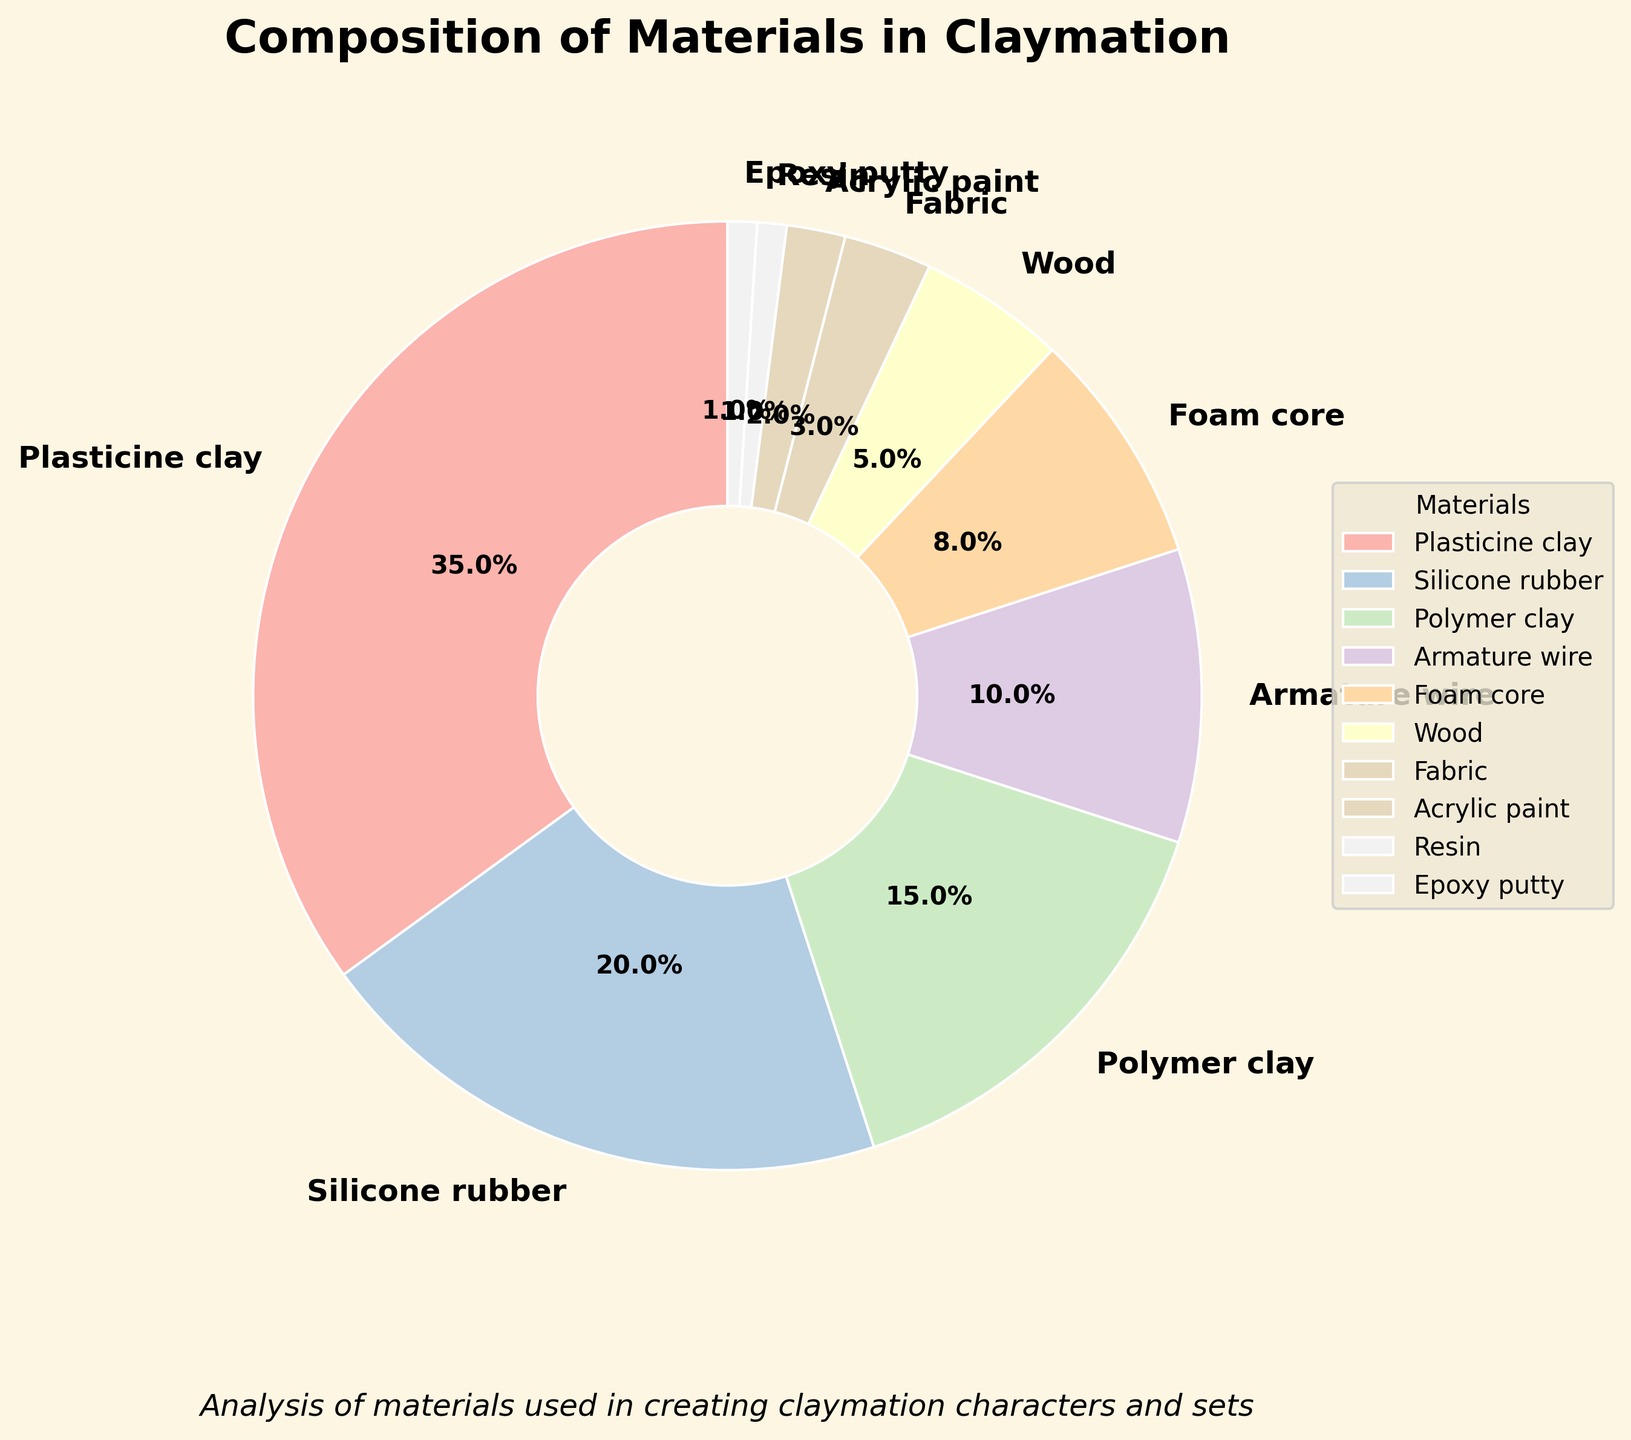Which material is used the most in creating claymation characters and sets? The pie chart shows different materials with their respective percentages. The largest segment corresponds to Plasticine clay with 35%.
Answer: Plasticine clay How much larger in percentage is Plasticine clay compared to Silicone rubber? From the pie chart, Plasticine clay is 35% and Silicone rubber is 20%. The difference is 35% - 20% which is 15%.
Answer: 15% What is the combined percentage of Polymer clay and Armature wire? According to the pie chart, Polymer clay accounts for 15% and Armature wire 10%. Adding these together gives 15% + 10% = 25%.
Answer: 25% Which material has the smallest percentage usage and what is it? By observing the pie chart, Resin and Epoxy putty both tie for the smallest segment at 1% each.
Answer: Resin and Epoxy putty Is the total percentage of Foam core and Fabric smaller or larger than Silicone rubber? Foam core has 8% and Fabric has 3%, making their combined percentage 8% + 3% = 11%. This is smaller than Silicone rubber's 20%.
Answer: Smaller Which material groupings, when summed, equal 50% of the total composition? From the chart, one combination is Plasticine clay (35%) + Polymer clay (15%) = 50%.
Answer: Plasticine clay and Polymer clay Among Silicone rubber, Wood, and Acrylic paint, which has the smallest contribution? The pie chart shows Silicone rubber at 20%, Wood at 5%, and Acrylic paint at 2%. Acrylic paint has the smallest contribution.
Answer: Acrylic paint How many materials have a percentage usage equal to or less than 5%? Observing the pie chart, Wood (5%), Fabric (3%), Acrylic paint (2%), Resin (1%), and Epoxy putty (1%) all fall into this category, totaling five materials.
Answer: 5 What is the average percentage usage for the top three materials? The top three materials by percentage are Plasticine clay (35%), Silicone rubber (20%), and Polymer clay (15%). Their average is (35% + 20% + 15%) / 3 ≈ 23.33%.
Answer: 23.33% How does the percentage usage of Armature wire compare to Foam core? According to the pie chart, Armature wire has 10% and Foam core has 8%, so Armature wire usage is 2% higher.
Answer: 2% higher 